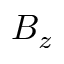Convert formula to latex. <formula><loc_0><loc_0><loc_500><loc_500>B _ { z }</formula> 